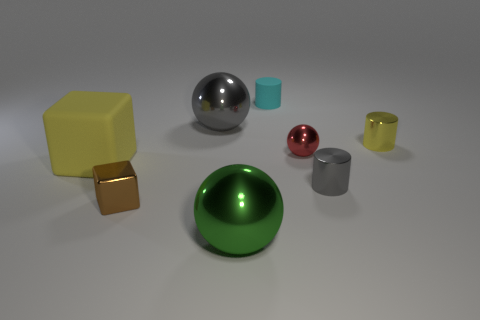The green object has what shape?
Make the answer very short. Sphere. Is the big sphere in front of the yellow shiny thing made of the same material as the yellow thing left of the large gray object?
Offer a very short reply. No. What shape is the large object that is behind the small red sphere?
Your response must be concise. Sphere. There is a red thing that is the same shape as the big green metal object; what is its size?
Your response must be concise. Small. Is there a small metal cube that is left of the gray shiny object to the left of the big green shiny ball?
Ensure brevity in your answer.  Yes. What is the color of the other thing that is the same shape as the brown thing?
Give a very brief answer. Yellow. How many things have the same color as the big block?
Ensure brevity in your answer.  1. What color is the tiny cylinder behind the large shiny sphere behind the small shiny cylinder that is behind the tiny ball?
Offer a terse response. Cyan. Is the brown block made of the same material as the tiny red sphere?
Offer a very short reply. Yes. Do the small cyan object and the red metallic thing have the same shape?
Ensure brevity in your answer.  No. 